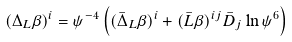Convert formula to latex. <formula><loc_0><loc_0><loc_500><loc_500>( \Delta _ { L } \beta ) ^ { i } = \psi ^ { - 4 } \left ( ( \bar { \Delta } _ { L } \beta ) ^ { i } + ( \bar { L } \beta ) ^ { i j } \bar { D } _ { j } \ln \psi ^ { 6 } \right )</formula> 